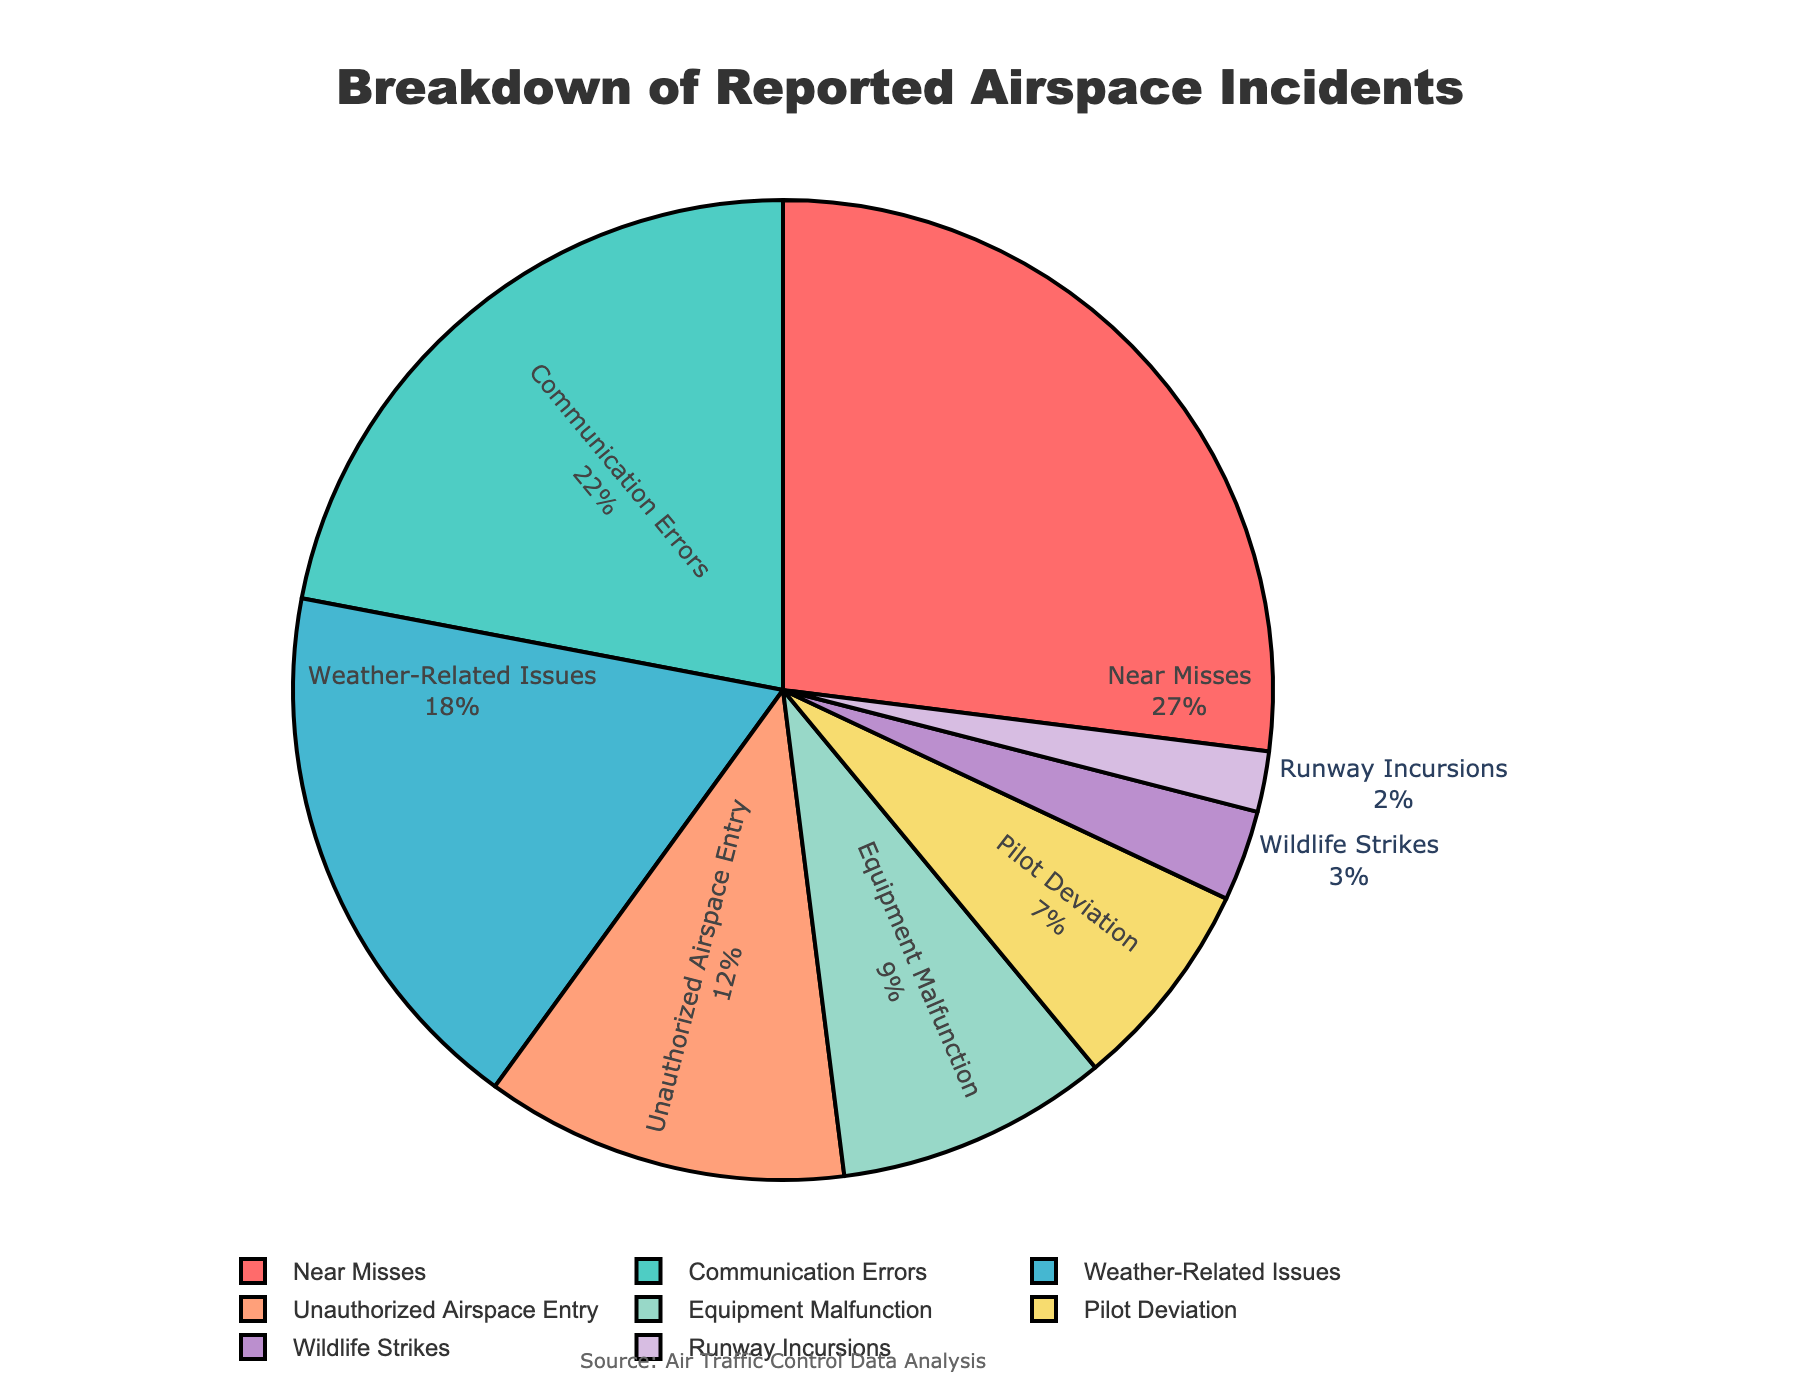What category has the highest percentage of reported incidents? The largest slice of the pie chart corresponds to Near Misses, with a percentage of 27%.
Answer: Near Misses Which two categories together account for nearly half of the reported airspace incidents? Adding the percentages for Near Misses (27%) and Communication Errors (22%) gives a total of 49%.
Answer: Near Misses and Communication Errors Is the percentage of Communication Errors higher than Weather-Related Issues? Communication Errors have a percentage of 22%, whereas Weather-Related Issues have a percentage of 18%. Therefore, the percentage of Communication Errors is higher.
Answer: Yes What is the combined percentage of Unauthorized Airspace Entry and Equipment Malfunction incidents? Adding the percentages for Unauthorized Airspace Entry (12%) and Equipment Malfunction (9%) gives a total of 21%.
Answer: 21% How does the percentage of Pilot Deviation compare to Wildlife Strikes? Pilot Deviation has a percentage of 7%, which is greater than the Wildlife Strikes' percentage of 3%.
Answer: Greater What is the sum of the percentages for incidents classified as Near Misses, Communication Errors, and Weather-Related Issues? Adding the percentages for Near Misses (27%), Communication Errors (22%), and Weather-Related Issues (18%) results in 67%.
Answer: 67% Are incidents due to Runway Incursions more or less than 5% of the total reported incidents? The percentage for Runway Incursions is 2%, which is less than 5%.
Answer: Less What is the smallest category of reported airspace incidents? The smallest slice of the pie chart is for Runway Incursions, which accounts for 2%.
Answer: Runway Incursions What percentage of incidents are due to equipment-related issues (combining Equipment Malfunction and Communication Errors)? Adding the percentages for Equipment Malfunction (9%) and Communication Errors (22%) gives a total of 31%.
Answer: 31% Does the color assigned to Weather-Related Issues appear before or after the color for Near Misses when moving clockwise from the top of the pie chart? Given the order, the color for Weather-Related Issues (probably '#45B7D1') appears after the color for Near Misses (probably '#FF6B6B') when moving clockwise.
Answer: After 